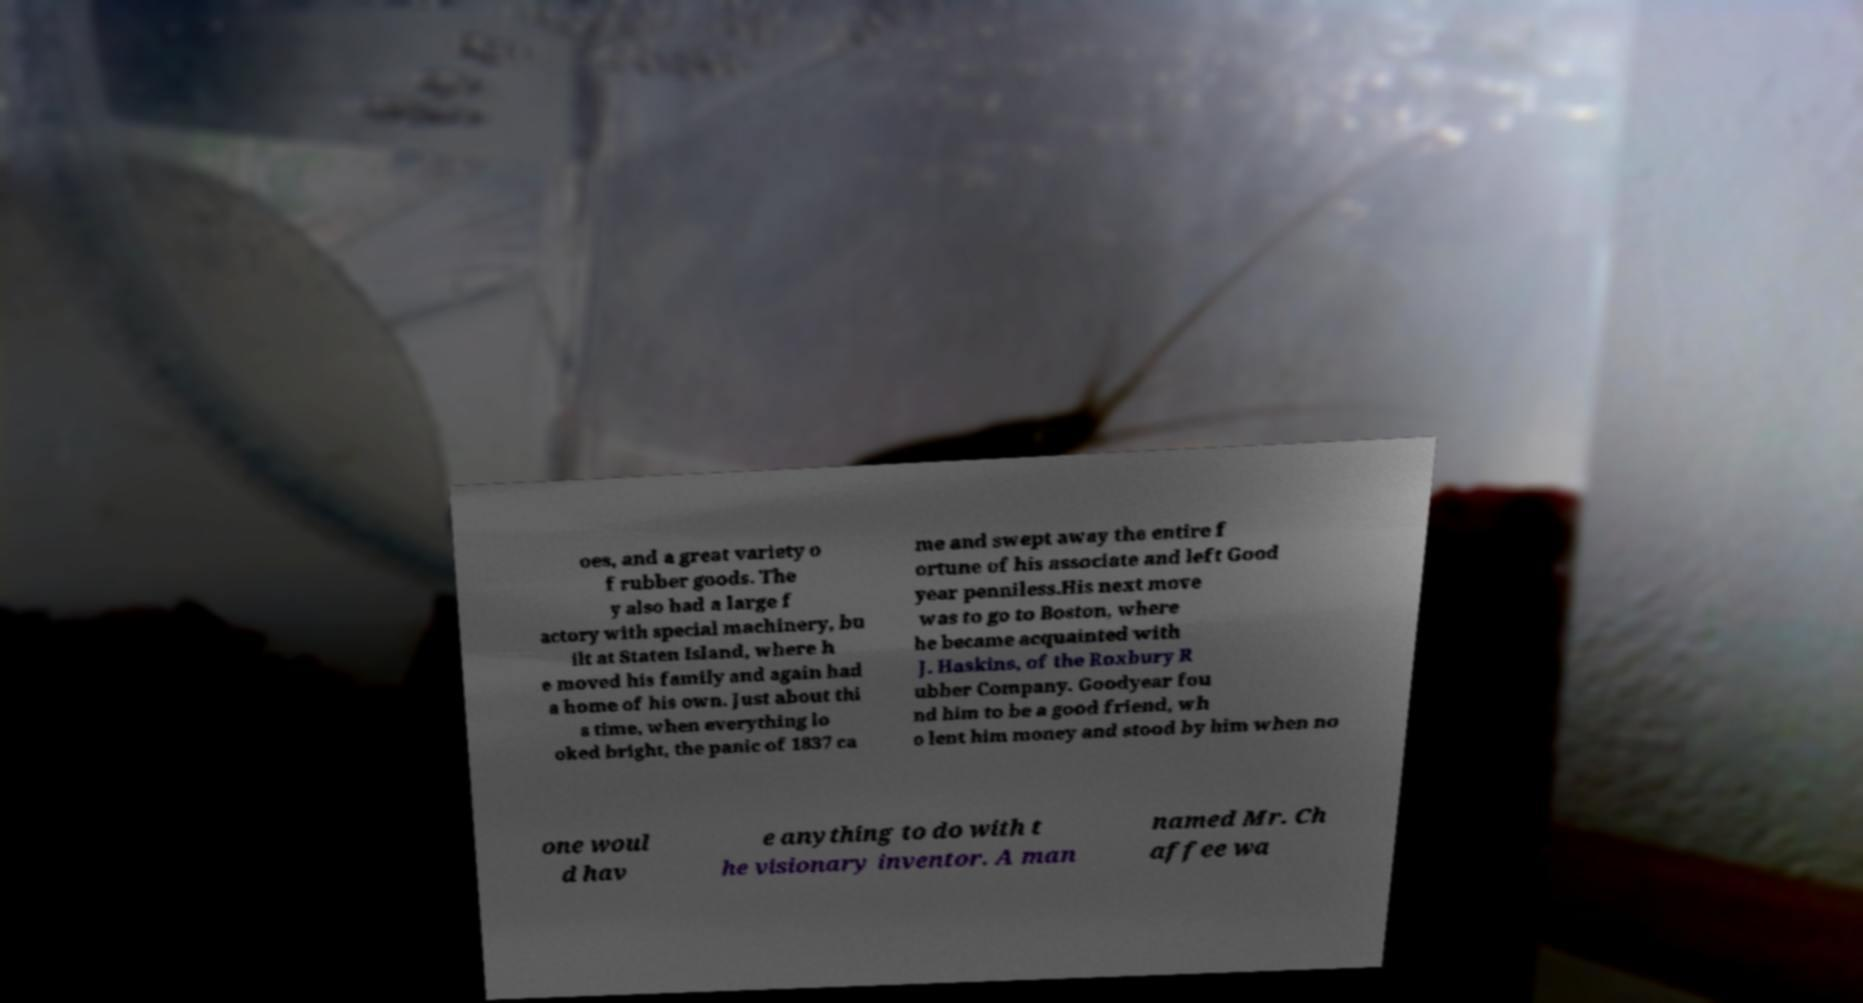Please read and relay the text visible in this image. What does it say? oes, and a great variety o f rubber goods. The y also had a large f actory with special machinery, bu ilt at Staten Island, where h e moved his family and again had a home of his own. Just about thi s time, when everything lo oked bright, the panic of 1837 ca me and swept away the entire f ortune of his associate and left Good year penniless.His next move was to go to Boston, where he became acquainted with J. Haskins, of the Roxbury R ubber Company. Goodyear fou nd him to be a good friend, wh o lent him money and stood by him when no one woul d hav e anything to do with t he visionary inventor. A man named Mr. Ch affee wa 